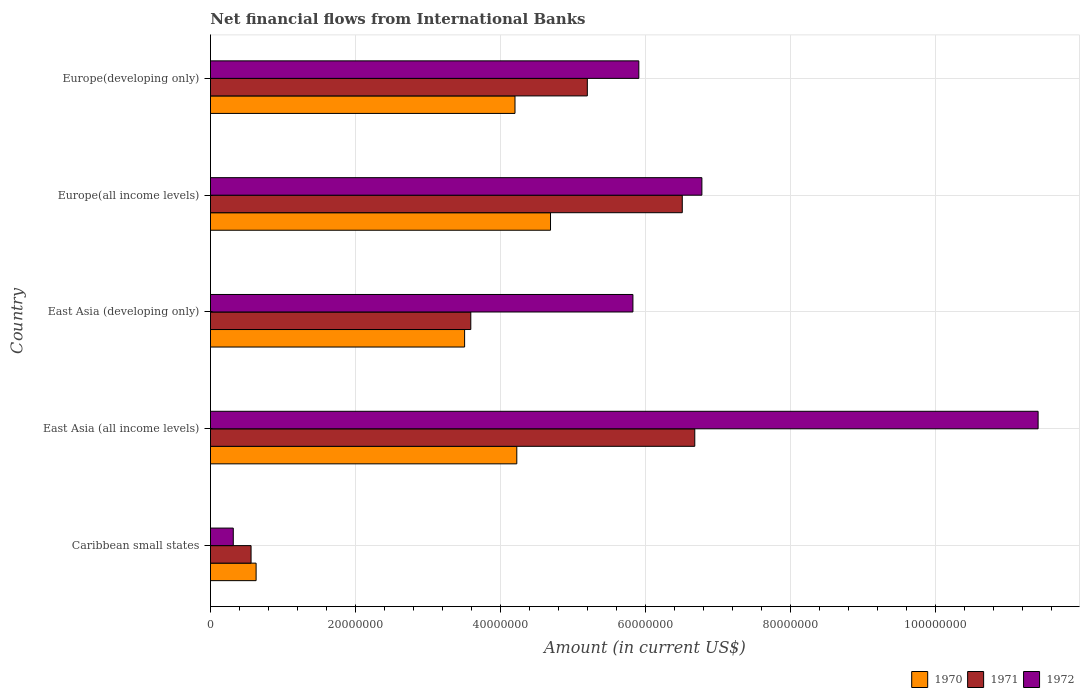Are the number of bars on each tick of the Y-axis equal?
Ensure brevity in your answer.  Yes. What is the label of the 1st group of bars from the top?
Make the answer very short. Europe(developing only). What is the net financial aid flows in 1970 in East Asia (developing only)?
Your response must be concise. 3.51e+07. Across all countries, what is the maximum net financial aid flows in 1970?
Make the answer very short. 4.69e+07. Across all countries, what is the minimum net financial aid flows in 1970?
Your answer should be compact. 6.30e+06. In which country was the net financial aid flows in 1971 maximum?
Offer a very short reply. East Asia (all income levels). In which country was the net financial aid flows in 1970 minimum?
Give a very brief answer. Caribbean small states. What is the total net financial aid flows in 1970 in the graph?
Your answer should be compact. 1.73e+08. What is the difference between the net financial aid flows in 1971 in Caribbean small states and that in East Asia (developing only)?
Your answer should be compact. -3.03e+07. What is the difference between the net financial aid flows in 1971 in East Asia (all income levels) and the net financial aid flows in 1970 in Europe(developing only)?
Your answer should be compact. 2.48e+07. What is the average net financial aid flows in 1970 per country?
Offer a terse response. 3.45e+07. What is the difference between the net financial aid flows in 1972 and net financial aid flows in 1970 in Europe(developing only)?
Offer a terse response. 1.71e+07. In how many countries, is the net financial aid flows in 1971 greater than 96000000 US$?
Offer a very short reply. 0. What is the ratio of the net financial aid flows in 1971 in Caribbean small states to that in East Asia (developing only)?
Keep it short and to the point. 0.16. What is the difference between the highest and the second highest net financial aid flows in 1970?
Your answer should be very brief. 4.65e+06. What is the difference between the highest and the lowest net financial aid flows in 1970?
Offer a terse response. 4.06e+07. Is the sum of the net financial aid flows in 1972 in East Asia (developing only) and Europe(developing only) greater than the maximum net financial aid flows in 1971 across all countries?
Provide a short and direct response. Yes. How many countries are there in the graph?
Your response must be concise. 5. Does the graph contain any zero values?
Provide a short and direct response. No. Does the graph contain grids?
Keep it short and to the point. Yes. How are the legend labels stacked?
Your answer should be compact. Horizontal. What is the title of the graph?
Keep it short and to the point. Net financial flows from International Banks. Does "2007" appear as one of the legend labels in the graph?
Ensure brevity in your answer.  No. What is the label or title of the Y-axis?
Make the answer very short. Country. What is the Amount (in current US$) in 1970 in Caribbean small states?
Your response must be concise. 6.30e+06. What is the Amount (in current US$) of 1971 in Caribbean small states?
Provide a short and direct response. 5.60e+06. What is the Amount (in current US$) of 1972 in Caribbean small states?
Your response must be concise. 3.15e+06. What is the Amount (in current US$) in 1970 in East Asia (all income levels)?
Ensure brevity in your answer.  4.23e+07. What is the Amount (in current US$) in 1971 in East Asia (all income levels)?
Your answer should be very brief. 6.68e+07. What is the Amount (in current US$) in 1972 in East Asia (all income levels)?
Give a very brief answer. 1.14e+08. What is the Amount (in current US$) in 1970 in East Asia (developing only)?
Your answer should be very brief. 3.51e+07. What is the Amount (in current US$) of 1971 in East Asia (developing only)?
Ensure brevity in your answer.  3.59e+07. What is the Amount (in current US$) in 1972 in East Asia (developing only)?
Make the answer very short. 5.83e+07. What is the Amount (in current US$) of 1970 in Europe(all income levels)?
Your response must be concise. 4.69e+07. What is the Amount (in current US$) of 1971 in Europe(all income levels)?
Offer a very short reply. 6.51e+07. What is the Amount (in current US$) in 1972 in Europe(all income levels)?
Your answer should be compact. 6.78e+07. What is the Amount (in current US$) of 1970 in Europe(developing only)?
Provide a succinct answer. 4.20e+07. What is the Amount (in current US$) of 1971 in Europe(developing only)?
Make the answer very short. 5.20e+07. What is the Amount (in current US$) in 1972 in Europe(developing only)?
Ensure brevity in your answer.  5.91e+07. Across all countries, what is the maximum Amount (in current US$) of 1970?
Keep it short and to the point. 4.69e+07. Across all countries, what is the maximum Amount (in current US$) in 1971?
Provide a succinct answer. 6.68e+07. Across all countries, what is the maximum Amount (in current US$) of 1972?
Ensure brevity in your answer.  1.14e+08. Across all countries, what is the minimum Amount (in current US$) of 1970?
Provide a short and direct response. 6.30e+06. Across all countries, what is the minimum Amount (in current US$) of 1971?
Offer a terse response. 5.60e+06. Across all countries, what is the minimum Amount (in current US$) of 1972?
Offer a terse response. 3.15e+06. What is the total Amount (in current US$) of 1970 in the graph?
Your answer should be compact. 1.73e+08. What is the total Amount (in current US$) in 1971 in the graph?
Your answer should be compact. 2.25e+08. What is the total Amount (in current US$) in 1972 in the graph?
Keep it short and to the point. 3.03e+08. What is the difference between the Amount (in current US$) in 1970 in Caribbean small states and that in East Asia (all income levels)?
Keep it short and to the point. -3.60e+07. What is the difference between the Amount (in current US$) of 1971 in Caribbean small states and that in East Asia (all income levels)?
Your response must be concise. -6.12e+07. What is the difference between the Amount (in current US$) in 1972 in Caribbean small states and that in East Asia (all income levels)?
Ensure brevity in your answer.  -1.11e+08. What is the difference between the Amount (in current US$) of 1970 in Caribbean small states and that in East Asia (developing only)?
Offer a very short reply. -2.88e+07. What is the difference between the Amount (in current US$) in 1971 in Caribbean small states and that in East Asia (developing only)?
Ensure brevity in your answer.  -3.03e+07. What is the difference between the Amount (in current US$) of 1972 in Caribbean small states and that in East Asia (developing only)?
Offer a terse response. -5.51e+07. What is the difference between the Amount (in current US$) of 1970 in Caribbean small states and that in Europe(all income levels)?
Make the answer very short. -4.06e+07. What is the difference between the Amount (in current US$) of 1971 in Caribbean small states and that in Europe(all income levels)?
Give a very brief answer. -5.95e+07. What is the difference between the Amount (in current US$) of 1972 in Caribbean small states and that in Europe(all income levels)?
Ensure brevity in your answer.  -6.46e+07. What is the difference between the Amount (in current US$) in 1970 in Caribbean small states and that in Europe(developing only)?
Make the answer very short. -3.57e+07. What is the difference between the Amount (in current US$) in 1971 in Caribbean small states and that in Europe(developing only)?
Offer a very short reply. -4.64e+07. What is the difference between the Amount (in current US$) in 1972 in Caribbean small states and that in Europe(developing only)?
Your answer should be very brief. -5.59e+07. What is the difference between the Amount (in current US$) in 1970 in East Asia (all income levels) and that in East Asia (developing only)?
Provide a short and direct response. 7.20e+06. What is the difference between the Amount (in current US$) in 1971 in East Asia (all income levels) and that in East Asia (developing only)?
Keep it short and to the point. 3.09e+07. What is the difference between the Amount (in current US$) in 1972 in East Asia (all income levels) and that in East Asia (developing only)?
Your response must be concise. 5.59e+07. What is the difference between the Amount (in current US$) in 1970 in East Asia (all income levels) and that in Europe(all income levels)?
Offer a terse response. -4.65e+06. What is the difference between the Amount (in current US$) in 1971 in East Asia (all income levels) and that in Europe(all income levels)?
Give a very brief answer. 1.72e+06. What is the difference between the Amount (in current US$) of 1972 in East Asia (all income levels) and that in Europe(all income levels)?
Provide a short and direct response. 4.64e+07. What is the difference between the Amount (in current US$) of 1970 in East Asia (all income levels) and that in Europe(developing only)?
Keep it short and to the point. 2.48e+05. What is the difference between the Amount (in current US$) of 1971 in East Asia (all income levels) and that in Europe(developing only)?
Ensure brevity in your answer.  1.48e+07. What is the difference between the Amount (in current US$) in 1972 in East Asia (all income levels) and that in Europe(developing only)?
Ensure brevity in your answer.  5.51e+07. What is the difference between the Amount (in current US$) in 1970 in East Asia (developing only) and that in Europe(all income levels)?
Ensure brevity in your answer.  -1.19e+07. What is the difference between the Amount (in current US$) in 1971 in East Asia (developing only) and that in Europe(all income levels)?
Give a very brief answer. -2.92e+07. What is the difference between the Amount (in current US$) of 1972 in East Asia (developing only) and that in Europe(all income levels)?
Offer a very short reply. -9.52e+06. What is the difference between the Amount (in current US$) in 1970 in East Asia (developing only) and that in Europe(developing only)?
Provide a short and direct response. -6.95e+06. What is the difference between the Amount (in current US$) in 1971 in East Asia (developing only) and that in Europe(developing only)?
Provide a succinct answer. -1.61e+07. What is the difference between the Amount (in current US$) of 1972 in East Asia (developing only) and that in Europe(developing only)?
Ensure brevity in your answer.  -8.15e+05. What is the difference between the Amount (in current US$) of 1970 in Europe(all income levels) and that in Europe(developing only)?
Your response must be concise. 4.90e+06. What is the difference between the Amount (in current US$) in 1971 in Europe(all income levels) and that in Europe(developing only)?
Ensure brevity in your answer.  1.31e+07. What is the difference between the Amount (in current US$) in 1972 in Europe(all income levels) and that in Europe(developing only)?
Keep it short and to the point. 8.70e+06. What is the difference between the Amount (in current US$) in 1970 in Caribbean small states and the Amount (in current US$) in 1971 in East Asia (all income levels)?
Make the answer very short. -6.05e+07. What is the difference between the Amount (in current US$) of 1970 in Caribbean small states and the Amount (in current US$) of 1972 in East Asia (all income levels)?
Give a very brief answer. -1.08e+08. What is the difference between the Amount (in current US$) in 1971 in Caribbean small states and the Amount (in current US$) in 1972 in East Asia (all income levels)?
Offer a very short reply. -1.09e+08. What is the difference between the Amount (in current US$) of 1970 in Caribbean small states and the Amount (in current US$) of 1971 in East Asia (developing only)?
Keep it short and to the point. -2.96e+07. What is the difference between the Amount (in current US$) of 1970 in Caribbean small states and the Amount (in current US$) of 1972 in East Asia (developing only)?
Your answer should be very brief. -5.20e+07. What is the difference between the Amount (in current US$) of 1971 in Caribbean small states and the Amount (in current US$) of 1972 in East Asia (developing only)?
Offer a very short reply. -5.27e+07. What is the difference between the Amount (in current US$) of 1970 in Caribbean small states and the Amount (in current US$) of 1971 in Europe(all income levels)?
Make the answer very short. -5.88e+07. What is the difference between the Amount (in current US$) in 1970 in Caribbean small states and the Amount (in current US$) in 1972 in Europe(all income levels)?
Provide a short and direct response. -6.15e+07. What is the difference between the Amount (in current US$) of 1971 in Caribbean small states and the Amount (in current US$) of 1972 in Europe(all income levels)?
Your response must be concise. -6.22e+07. What is the difference between the Amount (in current US$) in 1970 in Caribbean small states and the Amount (in current US$) in 1971 in Europe(developing only)?
Offer a terse response. -4.57e+07. What is the difference between the Amount (in current US$) of 1970 in Caribbean small states and the Amount (in current US$) of 1972 in Europe(developing only)?
Provide a short and direct response. -5.28e+07. What is the difference between the Amount (in current US$) of 1971 in Caribbean small states and the Amount (in current US$) of 1972 in Europe(developing only)?
Keep it short and to the point. -5.35e+07. What is the difference between the Amount (in current US$) in 1970 in East Asia (all income levels) and the Amount (in current US$) in 1971 in East Asia (developing only)?
Offer a terse response. 6.34e+06. What is the difference between the Amount (in current US$) in 1970 in East Asia (all income levels) and the Amount (in current US$) in 1972 in East Asia (developing only)?
Your response must be concise. -1.60e+07. What is the difference between the Amount (in current US$) in 1971 in East Asia (all income levels) and the Amount (in current US$) in 1972 in East Asia (developing only)?
Your response must be concise. 8.53e+06. What is the difference between the Amount (in current US$) in 1970 in East Asia (all income levels) and the Amount (in current US$) in 1971 in Europe(all income levels)?
Give a very brief answer. -2.28e+07. What is the difference between the Amount (in current US$) in 1970 in East Asia (all income levels) and the Amount (in current US$) in 1972 in Europe(all income levels)?
Your response must be concise. -2.55e+07. What is the difference between the Amount (in current US$) in 1971 in East Asia (all income levels) and the Amount (in current US$) in 1972 in Europe(all income levels)?
Make the answer very short. -9.81e+05. What is the difference between the Amount (in current US$) in 1970 in East Asia (all income levels) and the Amount (in current US$) in 1971 in Europe(developing only)?
Your response must be concise. -9.73e+06. What is the difference between the Amount (in current US$) in 1970 in East Asia (all income levels) and the Amount (in current US$) in 1972 in Europe(developing only)?
Your answer should be compact. -1.68e+07. What is the difference between the Amount (in current US$) in 1971 in East Asia (all income levels) and the Amount (in current US$) in 1972 in Europe(developing only)?
Your answer should be compact. 7.72e+06. What is the difference between the Amount (in current US$) of 1970 in East Asia (developing only) and the Amount (in current US$) of 1971 in Europe(all income levels)?
Make the answer very short. -3.00e+07. What is the difference between the Amount (in current US$) in 1970 in East Asia (developing only) and the Amount (in current US$) in 1972 in Europe(all income levels)?
Provide a short and direct response. -3.27e+07. What is the difference between the Amount (in current US$) of 1971 in East Asia (developing only) and the Amount (in current US$) of 1972 in Europe(all income levels)?
Give a very brief answer. -3.19e+07. What is the difference between the Amount (in current US$) in 1970 in East Asia (developing only) and the Amount (in current US$) in 1971 in Europe(developing only)?
Keep it short and to the point. -1.69e+07. What is the difference between the Amount (in current US$) in 1970 in East Asia (developing only) and the Amount (in current US$) in 1972 in Europe(developing only)?
Ensure brevity in your answer.  -2.40e+07. What is the difference between the Amount (in current US$) in 1971 in East Asia (developing only) and the Amount (in current US$) in 1972 in Europe(developing only)?
Give a very brief answer. -2.32e+07. What is the difference between the Amount (in current US$) of 1970 in Europe(all income levels) and the Amount (in current US$) of 1971 in Europe(developing only)?
Your answer should be compact. -5.08e+06. What is the difference between the Amount (in current US$) in 1970 in Europe(all income levels) and the Amount (in current US$) in 1972 in Europe(developing only)?
Provide a succinct answer. -1.22e+07. What is the difference between the Amount (in current US$) in 1971 in Europe(all income levels) and the Amount (in current US$) in 1972 in Europe(developing only)?
Your answer should be compact. 6.00e+06. What is the average Amount (in current US$) in 1970 per country?
Keep it short and to the point. 3.45e+07. What is the average Amount (in current US$) of 1971 per country?
Offer a terse response. 4.51e+07. What is the average Amount (in current US$) of 1972 per country?
Ensure brevity in your answer.  6.05e+07. What is the difference between the Amount (in current US$) of 1970 and Amount (in current US$) of 1971 in Caribbean small states?
Your response must be concise. 6.96e+05. What is the difference between the Amount (in current US$) of 1970 and Amount (in current US$) of 1972 in Caribbean small states?
Your response must be concise. 3.15e+06. What is the difference between the Amount (in current US$) in 1971 and Amount (in current US$) in 1972 in Caribbean small states?
Provide a succinct answer. 2.45e+06. What is the difference between the Amount (in current US$) of 1970 and Amount (in current US$) of 1971 in East Asia (all income levels)?
Your answer should be compact. -2.46e+07. What is the difference between the Amount (in current US$) of 1970 and Amount (in current US$) of 1972 in East Asia (all income levels)?
Your response must be concise. -7.19e+07. What is the difference between the Amount (in current US$) of 1971 and Amount (in current US$) of 1972 in East Asia (all income levels)?
Ensure brevity in your answer.  -4.74e+07. What is the difference between the Amount (in current US$) in 1970 and Amount (in current US$) in 1971 in East Asia (developing only)?
Your response must be concise. -8.55e+05. What is the difference between the Amount (in current US$) of 1970 and Amount (in current US$) of 1972 in East Asia (developing only)?
Provide a short and direct response. -2.32e+07. What is the difference between the Amount (in current US$) in 1971 and Amount (in current US$) in 1972 in East Asia (developing only)?
Your answer should be compact. -2.24e+07. What is the difference between the Amount (in current US$) in 1970 and Amount (in current US$) in 1971 in Europe(all income levels)?
Keep it short and to the point. -1.82e+07. What is the difference between the Amount (in current US$) in 1970 and Amount (in current US$) in 1972 in Europe(all income levels)?
Give a very brief answer. -2.09e+07. What is the difference between the Amount (in current US$) in 1971 and Amount (in current US$) in 1972 in Europe(all income levels)?
Give a very brief answer. -2.70e+06. What is the difference between the Amount (in current US$) of 1970 and Amount (in current US$) of 1971 in Europe(developing only)?
Provide a succinct answer. -9.98e+06. What is the difference between the Amount (in current US$) of 1970 and Amount (in current US$) of 1972 in Europe(developing only)?
Your answer should be compact. -1.71e+07. What is the difference between the Amount (in current US$) of 1971 and Amount (in current US$) of 1972 in Europe(developing only)?
Your response must be concise. -7.10e+06. What is the ratio of the Amount (in current US$) in 1970 in Caribbean small states to that in East Asia (all income levels)?
Make the answer very short. 0.15. What is the ratio of the Amount (in current US$) in 1971 in Caribbean small states to that in East Asia (all income levels)?
Ensure brevity in your answer.  0.08. What is the ratio of the Amount (in current US$) in 1972 in Caribbean small states to that in East Asia (all income levels)?
Your answer should be compact. 0.03. What is the ratio of the Amount (in current US$) of 1970 in Caribbean small states to that in East Asia (developing only)?
Your response must be concise. 0.18. What is the ratio of the Amount (in current US$) of 1971 in Caribbean small states to that in East Asia (developing only)?
Make the answer very short. 0.16. What is the ratio of the Amount (in current US$) of 1972 in Caribbean small states to that in East Asia (developing only)?
Offer a terse response. 0.05. What is the ratio of the Amount (in current US$) of 1970 in Caribbean small states to that in Europe(all income levels)?
Make the answer very short. 0.13. What is the ratio of the Amount (in current US$) in 1971 in Caribbean small states to that in Europe(all income levels)?
Offer a very short reply. 0.09. What is the ratio of the Amount (in current US$) of 1972 in Caribbean small states to that in Europe(all income levels)?
Your answer should be very brief. 0.05. What is the ratio of the Amount (in current US$) of 1970 in Caribbean small states to that in Europe(developing only)?
Ensure brevity in your answer.  0.15. What is the ratio of the Amount (in current US$) of 1971 in Caribbean small states to that in Europe(developing only)?
Offer a very short reply. 0.11. What is the ratio of the Amount (in current US$) of 1972 in Caribbean small states to that in Europe(developing only)?
Make the answer very short. 0.05. What is the ratio of the Amount (in current US$) of 1970 in East Asia (all income levels) to that in East Asia (developing only)?
Your response must be concise. 1.21. What is the ratio of the Amount (in current US$) in 1971 in East Asia (all income levels) to that in East Asia (developing only)?
Keep it short and to the point. 1.86. What is the ratio of the Amount (in current US$) in 1972 in East Asia (all income levels) to that in East Asia (developing only)?
Keep it short and to the point. 1.96. What is the ratio of the Amount (in current US$) of 1970 in East Asia (all income levels) to that in Europe(all income levels)?
Make the answer very short. 0.9. What is the ratio of the Amount (in current US$) in 1971 in East Asia (all income levels) to that in Europe(all income levels)?
Your response must be concise. 1.03. What is the ratio of the Amount (in current US$) of 1972 in East Asia (all income levels) to that in Europe(all income levels)?
Offer a terse response. 1.68. What is the ratio of the Amount (in current US$) in 1970 in East Asia (all income levels) to that in Europe(developing only)?
Provide a short and direct response. 1.01. What is the ratio of the Amount (in current US$) of 1971 in East Asia (all income levels) to that in Europe(developing only)?
Ensure brevity in your answer.  1.29. What is the ratio of the Amount (in current US$) in 1972 in East Asia (all income levels) to that in Europe(developing only)?
Your response must be concise. 1.93. What is the ratio of the Amount (in current US$) of 1970 in East Asia (developing only) to that in Europe(all income levels)?
Give a very brief answer. 0.75. What is the ratio of the Amount (in current US$) of 1971 in East Asia (developing only) to that in Europe(all income levels)?
Provide a succinct answer. 0.55. What is the ratio of the Amount (in current US$) of 1972 in East Asia (developing only) to that in Europe(all income levels)?
Provide a succinct answer. 0.86. What is the ratio of the Amount (in current US$) of 1970 in East Asia (developing only) to that in Europe(developing only)?
Give a very brief answer. 0.83. What is the ratio of the Amount (in current US$) of 1971 in East Asia (developing only) to that in Europe(developing only)?
Your answer should be compact. 0.69. What is the ratio of the Amount (in current US$) of 1972 in East Asia (developing only) to that in Europe(developing only)?
Your answer should be very brief. 0.99. What is the ratio of the Amount (in current US$) in 1970 in Europe(all income levels) to that in Europe(developing only)?
Keep it short and to the point. 1.12. What is the ratio of the Amount (in current US$) of 1971 in Europe(all income levels) to that in Europe(developing only)?
Offer a terse response. 1.25. What is the ratio of the Amount (in current US$) in 1972 in Europe(all income levels) to that in Europe(developing only)?
Offer a terse response. 1.15. What is the difference between the highest and the second highest Amount (in current US$) of 1970?
Ensure brevity in your answer.  4.65e+06. What is the difference between the highest and the second highest Amount (in current US$) of 1971?
Provide a short and direct response. 1.72e+06. What is the difference between the highest and the second highest Amount (in current US$) of 1972?
Ensure brevity in your answer.  4.64e+07. What is the difference between the highest and the lowest Amount (in current US$) of 1970?
Your response must be concise. 4.06e+07. What is the difference between the highest and the lowest Amount (in current US$) of 1971?
Ensure brevity in your answer.  6.12e+07. What is the difference between the highest and the lowest Amount (in current US$) of 1972?
Your answer should be very brief. 1.11e+08. 